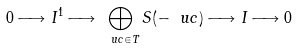Convert formula to latex. <formula><loc_0><loc_0><loc_500><loc_500>0 \longrightarrow I ^ { 1 } \longrightarrow \bigoplus _ { \ u c \in T } S ( - \ u c ) \longrightarrow I \longrightarrow 0</formula> 